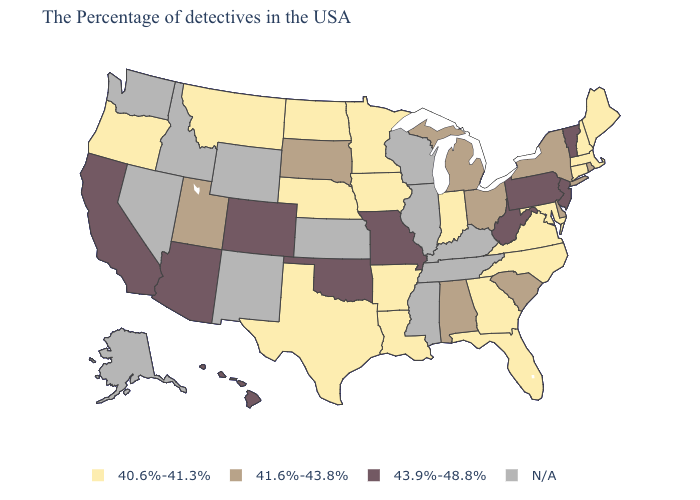What is the highest value in states that border Maine?
Give a very brief answer. 40.6%-41.3%. What is the value of Indiana?
Give a very brief answer. 40.6%-41.3%. How many symbols are there in the legend?
Be succinct. 4. Which states hav the highest value in the MidWest?
Quick response, please. Missouri. What is the value of Oklahoma?
Give a very brief answer. 43.9%-48.8%. Does Montana have the highest value in the West?
Write a very short answer. No. Name the states that have a value in the range 43.9%-48.8%?
Answer briefly. Vermont, New Jersey, Pennsylvania, West Virginia, Missouri, Oklahoma, Colorado, Arizona, California, Hawaii. Among the states that border Oregon , which have the lowest value?
Quick response, please. California. Does the first symbol in the legend represent the smallest category?
Quick response, please. Yes. Does Oregon have the lowest value in the West?
Concise answer only. Yes. Which states hav the highest value in the Northeast?
Quick response, please. Vermont, New Jersey, Pennsylvania. 